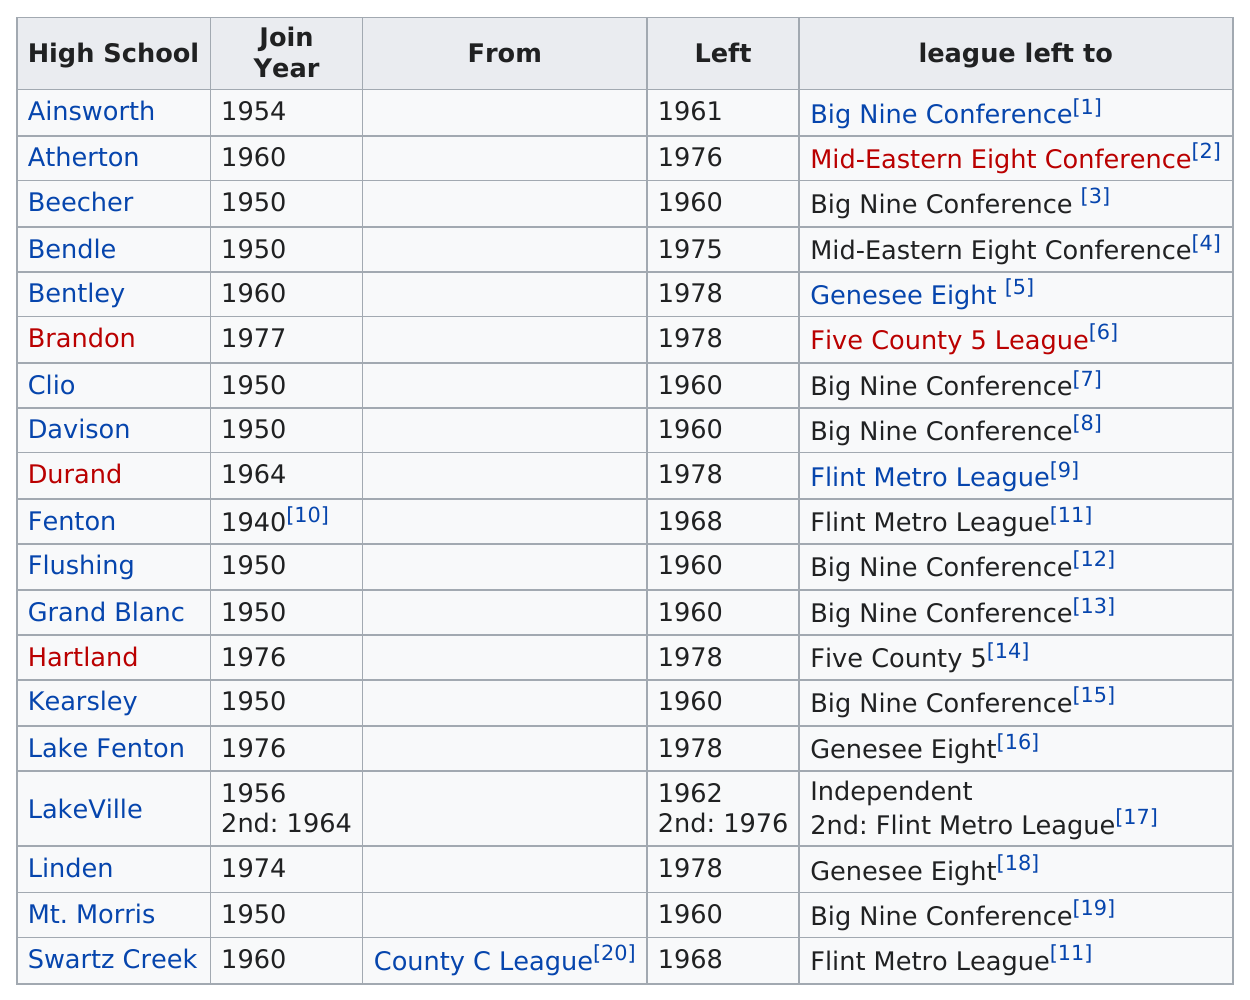Point out several critical features in this image. Did more schools leave in 1960 or 1978? 1960... Bendle School was left before Beecher School because Beecher School was left before Bendle School. In Genesee County, before Ainsworth, a total of 7 schools left the B League. The last school to join the Genesee County B League was Brandon. The difference between the year Clio left and the year Atherton left is 16... 